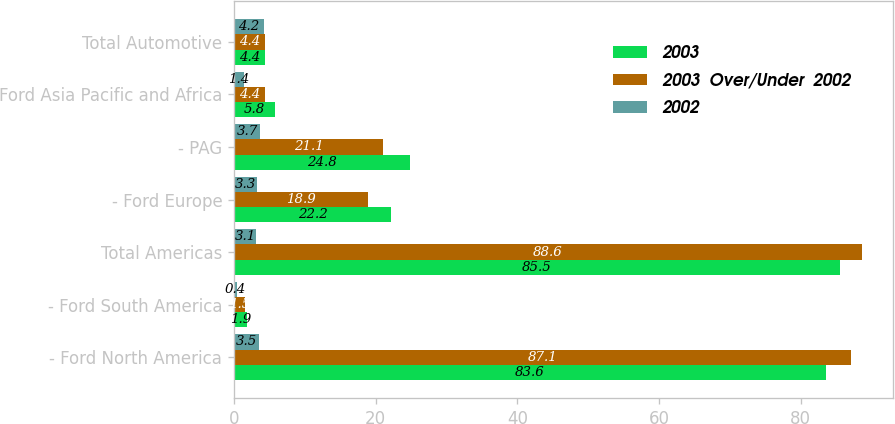Convert chart to OTSL. <chart><loc_0><loc_0><loc_500><loc_500><stacked_bar_chart><ecel><fcel>- Ford North America<fcel>- Ford South America<fcel>Total Americas<fcel>- Ford Europe<fcel>- PAG<fcel>Ford Asia Pacific and Africa<fcel>Total Automotive<nl><fcel>2003<fcel>83.6<fcel>1.9<fcel>85.5<fcel>22.2<fcel>24.8<fcel>5.8<fcel>4.4<nl><fcel>2003  Over/Under  2002<fcel>87.1<fcel>1.5<fcel>88.6<fcel>18.9<fcel>21.1<fcel>4.4<fcel>4.4<nl><fcel>2002<fcel>3.5<fcel>0.4<fcel>3.1<fcel>3.3<fcel>3.7<fcel>1.4<fcel>4.2<nl></chart> 